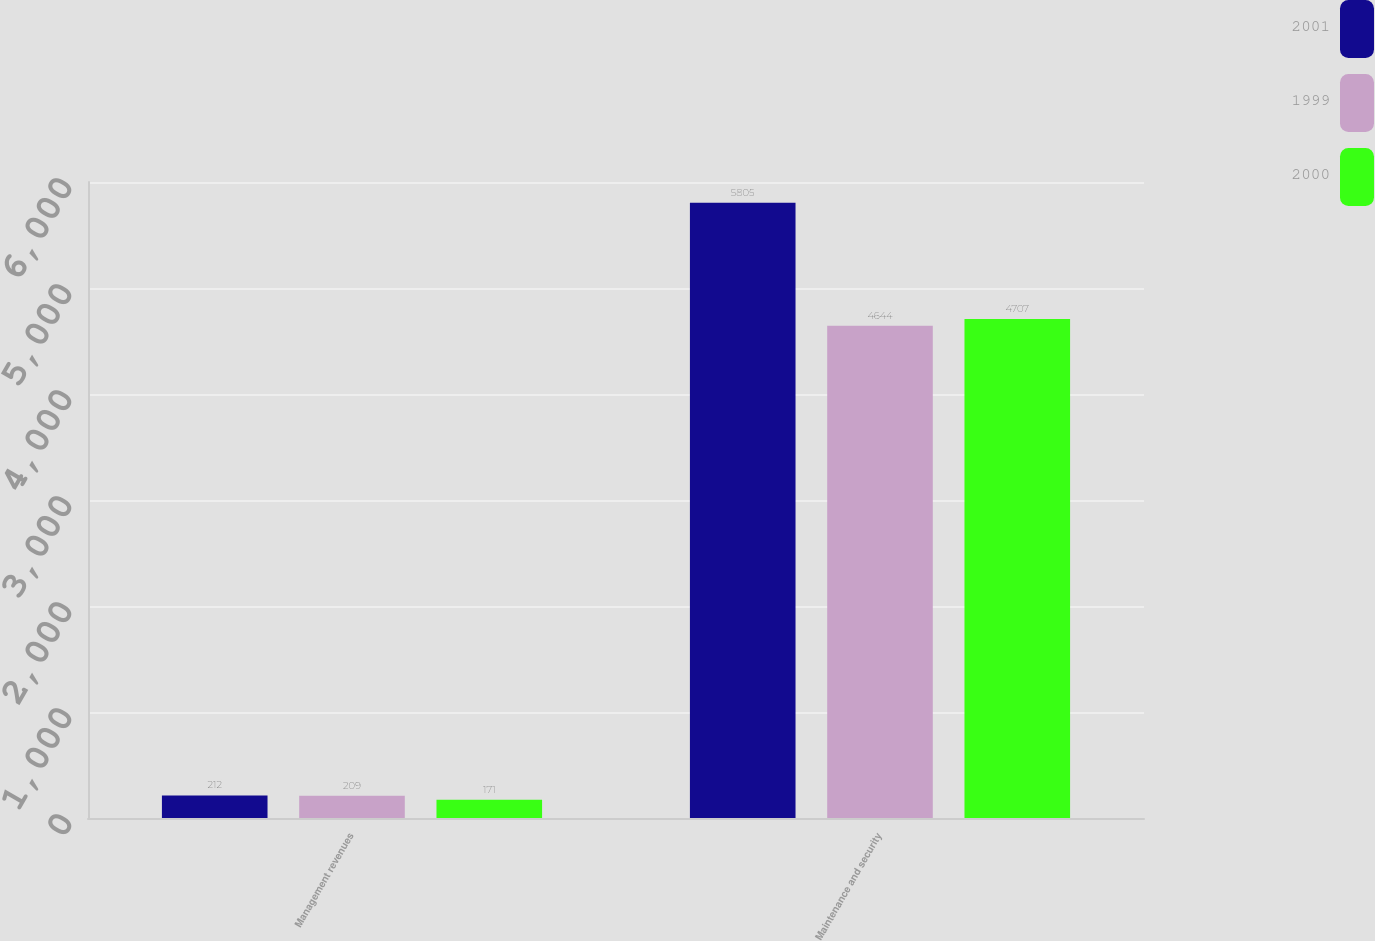Convert chart to OTSL. <chart><loc_0><loc_0><loc_500><loc_500><stacked_bar_chart><ecel><fcel>Management revenues<fcel>Maintenance and security<nl><fcel>2001<fcel>212<fcel>5805<nl><fcel>1999<fcel>209<fcel>4644<nl><fcel>2000<fcel>171<fcel>4707<nl></chart> 